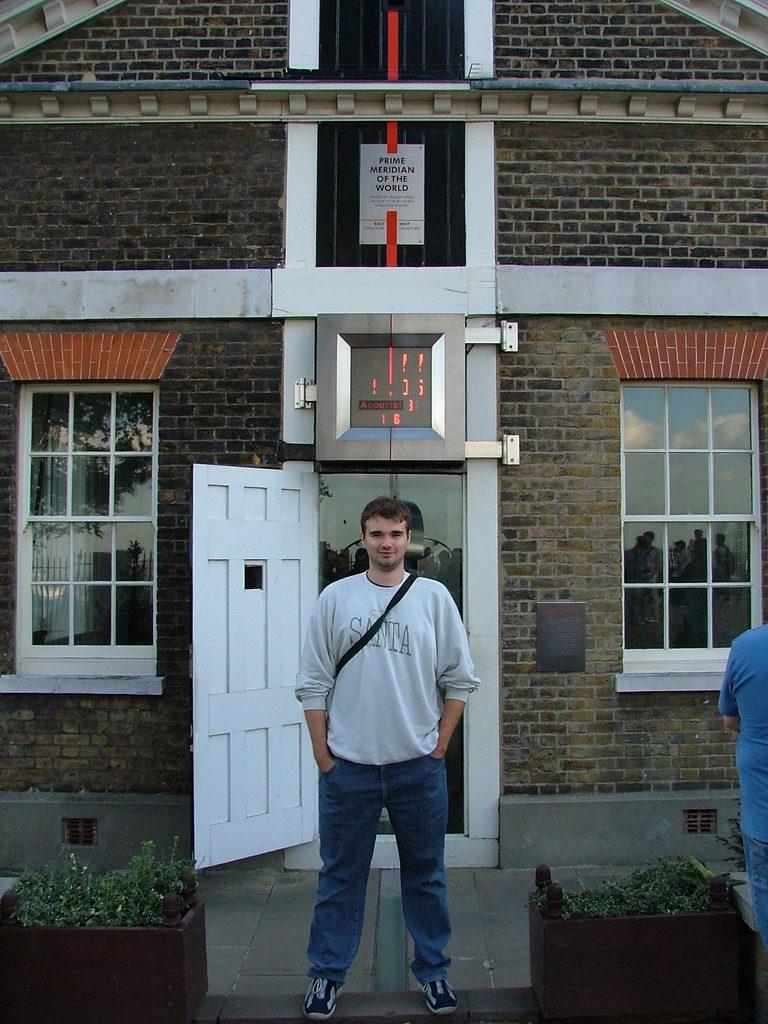What is the the mans shirt?
Provide a succinct answer. Santa. 